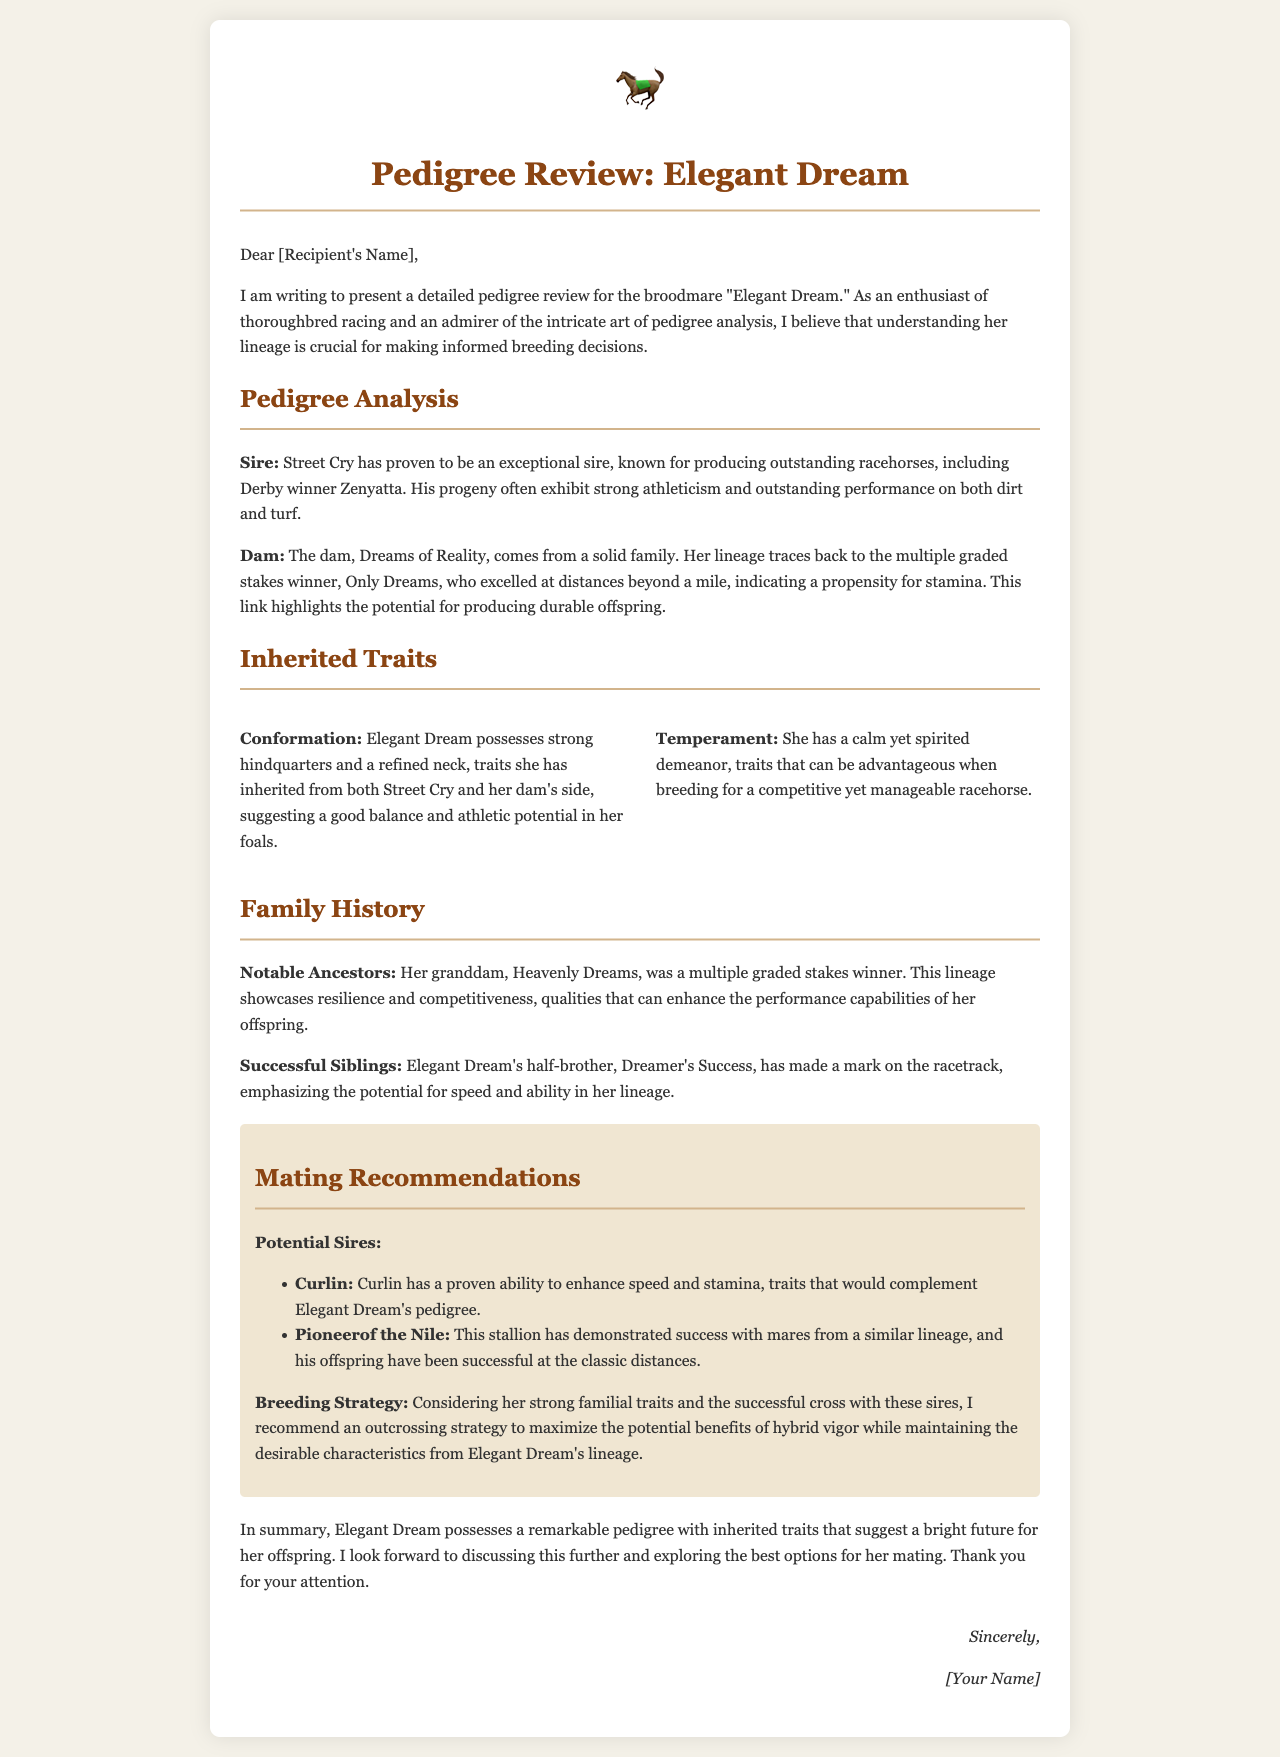What is the name of the broodmare? The letter explicitly refers to the broodmare as "Elegant Dream."
Answer: Elegant Dream Who is the sire of Elegant Dream? The document names "Street Cry" as the sire of Elegant Dream.
Answer: Street Cry What notable ancestor is mentioned for Elegant Dream? The review highlights "Heavenly Dreams" as a notable ancestor.
Answer: Heavenly Dreams Which stallion is recommended for speed and stamina enhancement? The letter suggests "Curlin" for enhancing speed and stamina traits.
Answer: Curlin What is the temperament of Elegant Dream described as? The letter describes Elegant Dream's temperament as "calm yet spirited."
Answer: calm yet spirited What is the breeding strategy recommended for Elegant Dream? The document recommends an "outcrossing strategy" for breeding.
Answer: outcrossing strategy How many successful siblings are mentioned for Elegant Dream? The review specifically mentions one successful sibling, "Dreamer's Success."
Answer: one What is the relationship of Dreams of Reality to Elegant Dream? Dreams of Reality is the dam of Elegant Dream.
Answer: dam What unique trait does Elegant Dream inherit from her sire? She inherits strong athleticism from her sire, Street Cry.
Answer: strong athleticism 